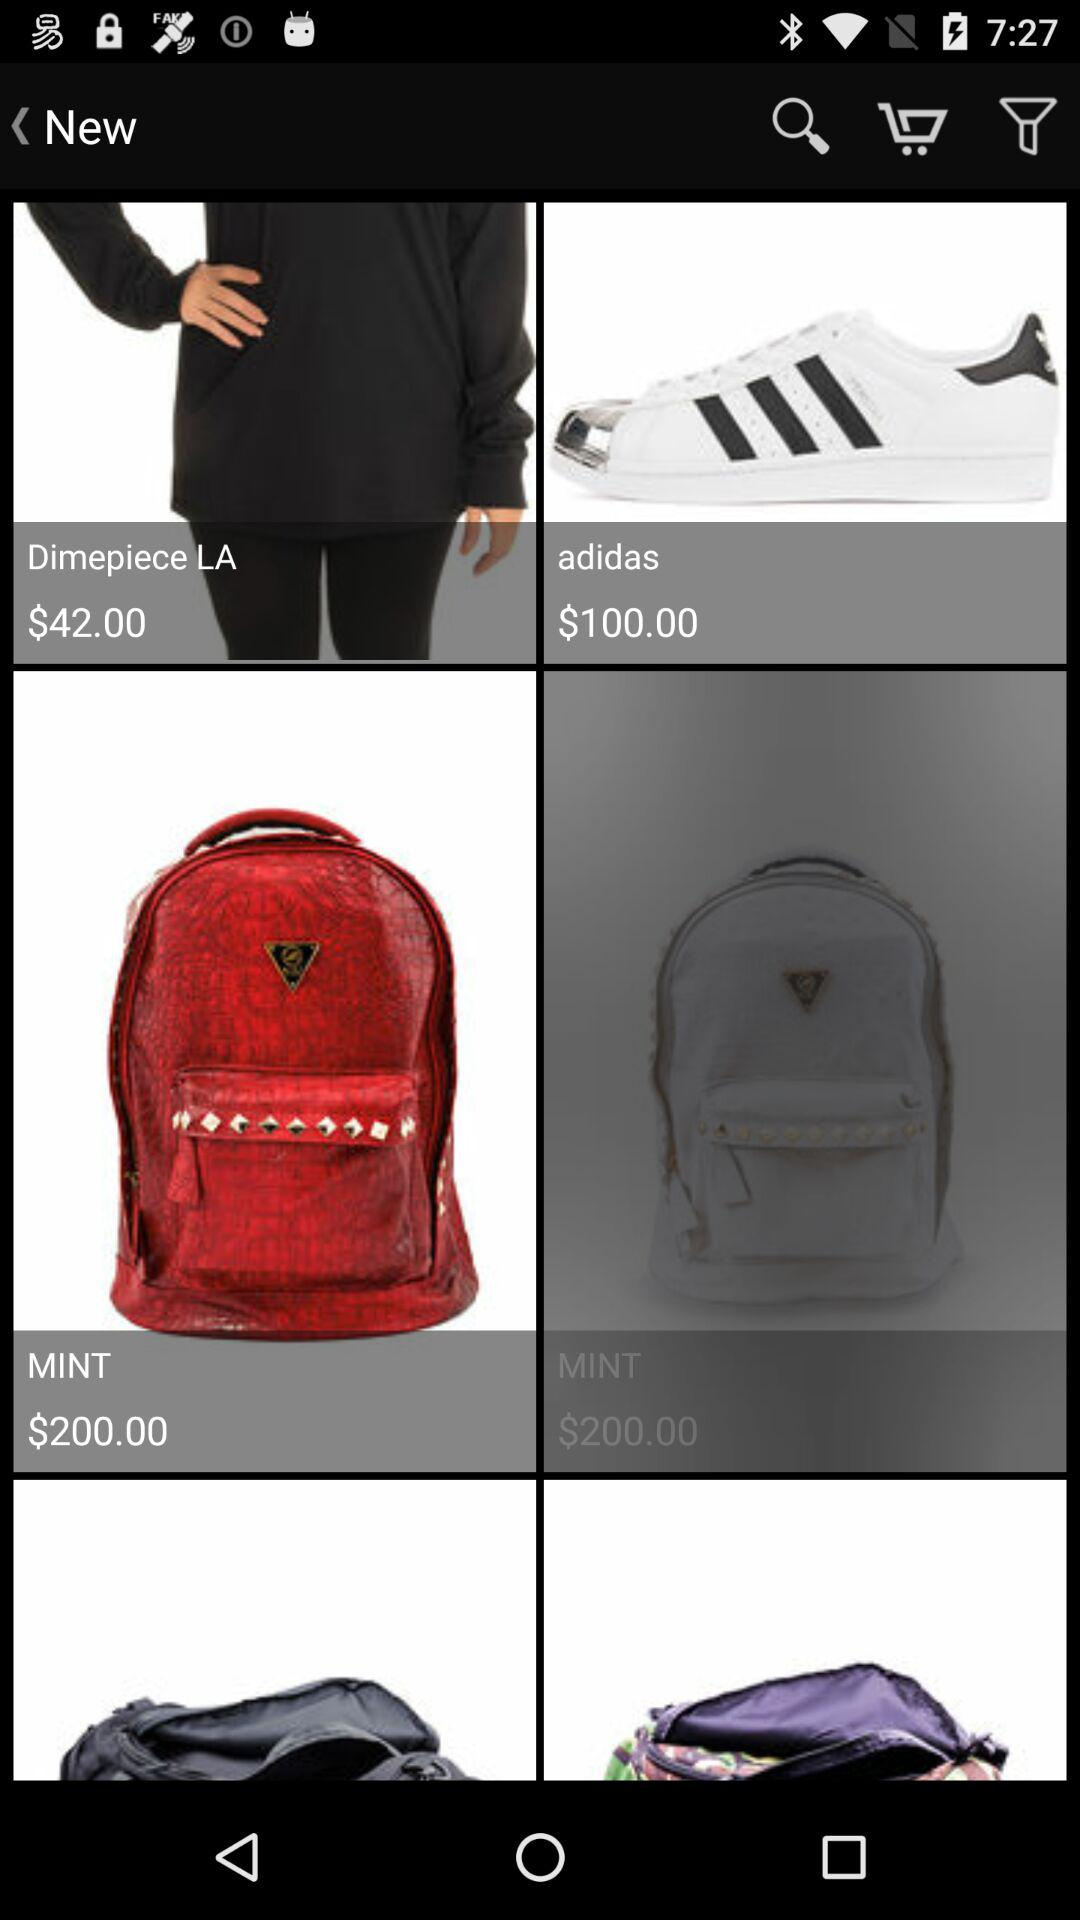How many items are in the cart?
When the provided information is insufficient, respond with <no answer>. <no answer> 